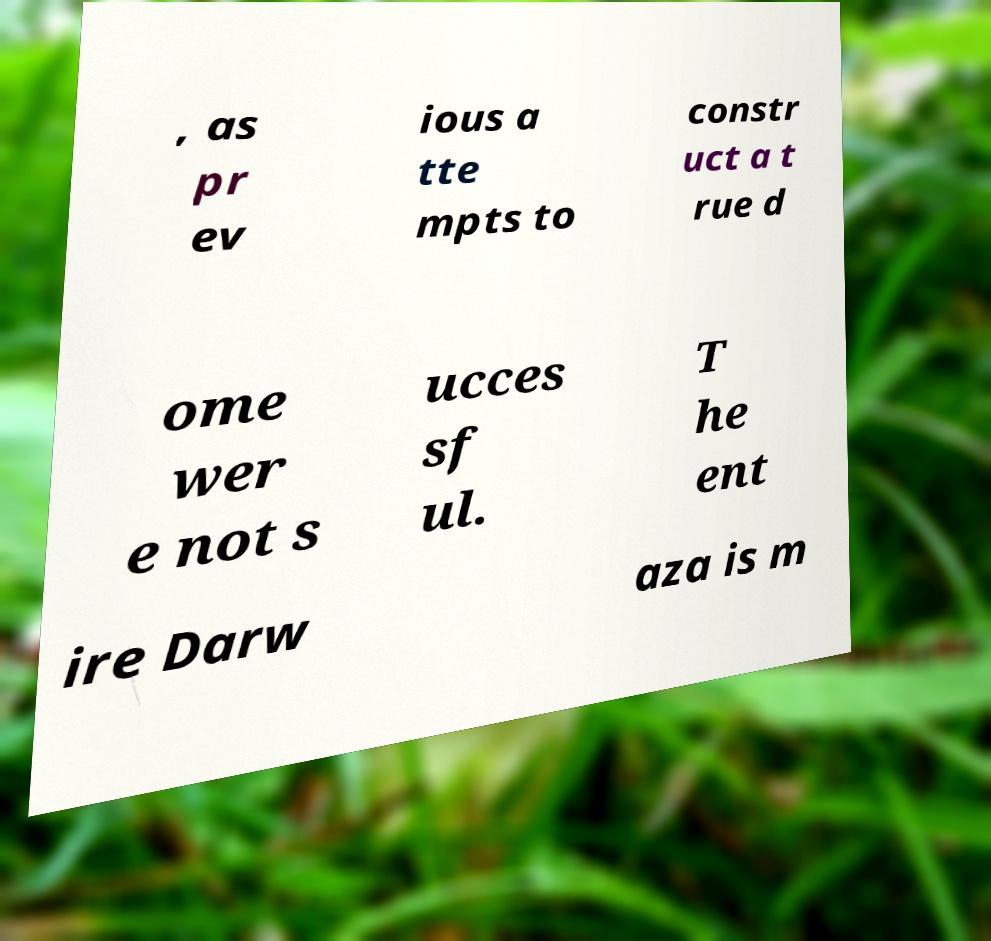Can you accurately transcribe the text from the provided image for me? , as pr ev ious a tte mpts to constr uct a t rue d ome wer e not s ucces sf ul. T he ent ire Darw aza is m 